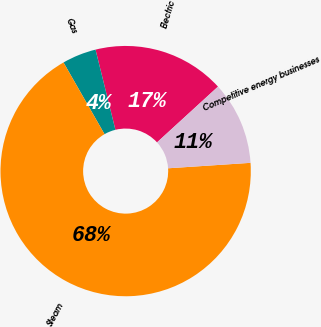Convert chart to OTSL. <chart><loc_0><loc_0><loc_500><loc_500><pie_chart><fcel>Electric<fcel>Gas<fcel>Steam<fcel>Competitive energy businesses<nl><fcel>17.08%<fcel>4.4%<fcel>67.78%<fcel>10.74%<nl></chart> 